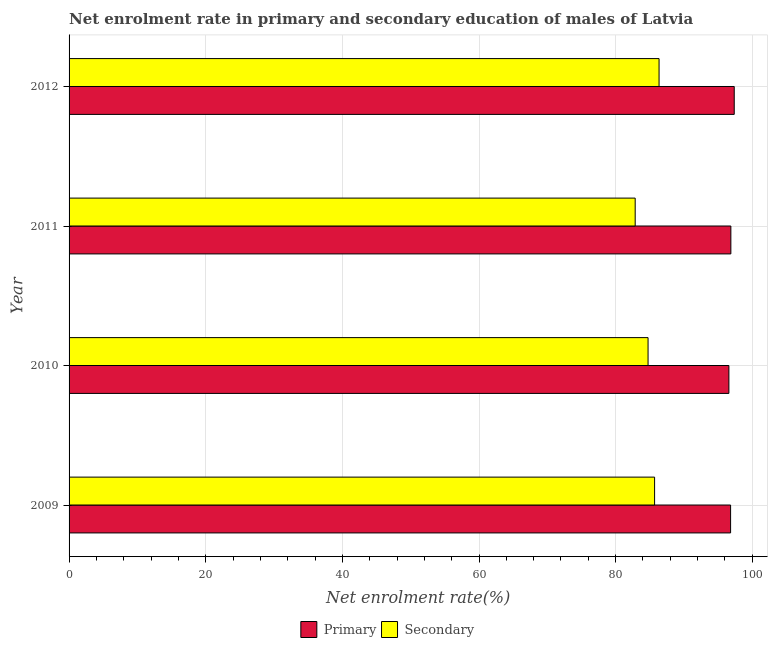Are the number of bars per tick equal to the number of legend labels?
Make the answer very short. Yes. Are the number of bars on each tick of the Y-axis equal?
Give a very brief answer. Yes. In how many cases, is the number of bars for a given year not equal to the number of legend labels?
Give a very brief answer. 0. What is the enrollment rate in primary education in 2009?
Offer a very short reply. 96.82. Across all years, what is the maximum enrollment rate in secondary education?
Give a very brief answer. 86.36. Across all years, what is the minimum enrollment rate in primary education?
Offer a terse response. 96.58. In which year was the enrollment rate in primary education maximum?
Your answer should be very brief. 2012. In which year was the enrollment rate in primary education minimum?
Give a very brief answer. 2010. What is the total enrollment rate in secondary education in the graph?
Provide a short and direct response. 339.66. What is the difference between the enrollment rate in primary education in 2011 and that in 2012?
Keep it short and to the point. -0.49. What is the difference between the enrollment rate in secondary education in 2009 and the enrollment rate in primary education in 2010?
Your response must be concise. -10.88. What is the average enrollment rate in primary education per year?
Your answer should be very brief. 96.91. In the year 2012, what is the difference between the enrollment rate in primary education and enrollment rate in secondary education?
Make the answer very short. 11. In how many years, is the enrollment rate in primary education greater than 64 %?
Your answer should be compact. 4. Is the enrollment rate in secondary education in 2009 less than that in 2012?
Provide a short and direct response. Yes. What is the difference between the highest and the second highest enrollment rate in primary education?
Your answer should be compact. 0.49. What is the difference between the highest and the lowest enrollment rate in secondary education?
Give a very brief answer. 3.49. What does the 1st bar from the top in 2012 represents?
Your answer should be compact. Secondary. What does the 2nd bar from the bottom in 2011 represents?
Offer a terse response. Secondary. How many bars are there?
Your response must be concise. 8. Are all the bars in the graph horizontal?
Provide a short and direct response. Yes. How many years are there in the graph?
Ensure brevity in your answer.  4. Does the graph contain grids?
Provide a succinct answer. Yes. How many legend labels are there?
Your answer should be very brief. 2. What is the title of the graph?
Keep it short and to the point. Net enrolment rate in primary and secondary education of males of Latvia. Does "National Tourists" appear as one of the legend labels in the graph?
Your response must be concise. No. What is the label or title of the X-axis?
Give a very brief answer. Net enrolment rate(%). What is the label or title of the Y-axis?
Your answer should be very brief. Year. What is the Net enrolment rate(%) of Primary in 2009?
Your answer should be very brief. 96.82. What is the Net enrolment rate(%) of Secondary in 2009?
Offer a very short reply. 85.7. What is the Net enrolment rate(%) of Primary in 2010?
Your answer should be very brief. 96.58. What is the Net enrolment rate(%) in Secondary in 2010?
Give a very brief answer. 84.74. What is the Net enrolment rate(%) in Primary in 2011?
Give a very brief answer. 96.86. What is the Net enrolment rate(%) in Secondary in 2011?
Your answer should be very brief. 82.86. What is the Net enrolment rate(%) in Primary in 2012?
Provide a succinct answer. 97.36. What is the Net enrolment rate(%) of Secondary in 2012?
Provide a short and direct response. 86.36. Across all years, what is the maximum Net enrolment rate(%) of Primary?
Give a very brief answer. 97.36. Across all years, what is the maximum Net enrolment rate(%) in Secondary?
Provide a short and direct response. 86.36. Across all years, what is the minimum Net enrolment rate(%) in Primary?
Make the answer very short. 96.58. Across all years, what is the minimum Net enrolment rate(%) in Secondary?
Give a very brief answer. 82.86. What is the total Net enrolment rate(%) in Primary in the graph?
Your answer should be very brief. 387.62. What is the total Net enrolment rate(%) in Secondary in the graph?
Your answer should be very brief. 339.66. What is the difference between the Net enrolment rate(%) of Primary in 2009 and that in 2010?
Give a very brief answer. 0.25. What is the difference between the Net enrolment rate(%) in Secondary in 2009 and that in 2010?
Offer a terse response. 0.96. What is the difference between the Net enrolment rate(%) in Primary in 2009 and that in 2011?
Give a very brief answer. -0.04. What is the difference between the Net enrolment rate(%) of Secondary in 2009 and that in 2011?
Offer a terse response. 2.84. What is the difference between the Net enrolment rate(%) in Primary in 2009 and that in 2012?
Keep it short and to the point. -0.53. What is the difference between the Net enrolment rate(%) in Secondary in 2009 and that in 2012?
Your response must be concise. -0.65. What is the difference between the Net enrolment rate(%) of Primary in 2010 and that in 2011?
Keep it short and to the point. -0.29. What is the difference between the Net enrolment rate(%) in Secondary in 2010 and that in 2011?
Keep it short and to the point. 1.88. What is the difference between the Net enrolment rate(%) in Primary in 2010 and that in 2012?
Keep it short and to the point. -0.78. What is the difference between the Net enrolment rate(%) of Secondary in 2010 and that in 2012?
Make the answer very short. -1.61. What is the difference between the Net enrolment rate(%) in Primary in 2011 and that in 2012?
Your response must be concise. -0.49. What is the difference between the Net enrolment rate(%) of Secondary in 2011 and that in 2012?
Ensure brevity in your answer.  -3.49. What is the difference between the Net enrolment rate(%) of Primary in 2009 and the Net enrolment rate(%) of Secondary in 2010?
Your response must be concise. 12.08. What is the difference between the Net enrolment rate(%) in Primary in 2009 and the Net enrolment rate(%) in Secondary in 2011?
Your response must be concise. 13.96. What is the difference between the Net enrolment rate(%) of Primary in 2009 and the Net enrolment rate(%) of Secondary in 2012?
Offer a very short reply. 10.47. What is the difference between the Net enrolment rate(%) in Primary in 2010 and the Net enrolment rate(%) in Secondary in 2011?
Provide a short and direct response. 13.72. What is the difference between the Net enrolment rate(%) in Primary in 2010 and the Net enrolment rate(%) in Secondary in 2012?
Your answer should be very brief. 10.22. What is the difference between the Net enrolment rate(%) of Primary in 2011 and the Net enrolment rate(%) of Secondary in 2012?
Offer a very short reply. 10.51. What is the average Net enrolment rate(%) of Primary per year?
Provide a short and direct response. 96.91. What is the average Net enrolment rate(%) in Secondary per year?
Offer a terse response. 84.92. In the year 2009, what is the difference between the Net enrolment rate(%) in Primary and Net enrolment rate(%) in Secondary?
Ensure brevity in your answer.  11.12. In the year 2010, what is the difference between the Net enrolment rate(%) of Primary and Net enrolment rate(%) of Secondary?
Offer a terse response. 11.83. In the year 2011, what is the difference between the Net enrolment rate(%) in Primary and Net enrolment rate(%) in Secondary?
Offer a terse response. 14. In the year 2012, what is the difference between the Net enrolment rate(%) of Primary and Net enrolment rate(%) of Secondary?
Keep it short and to the point. 11. What is the ratio of the Net enrolment rate(%) of Secondary in 2009 to that in 2010?
Your answer should be compact. 1.01. What is the ratio of the Net enrolment rate(%) of Primary in 2009 to that in 2011?
Offer a very short reply. 1. What is the ratio of the Net enrolment rate(%) of Secondary in 2009 to that in 2011?
Your response must be concise. 1.03. What is the ratio of the Net enrolment rate(%) of Primary in 2009 to that in 2012?
Your response must be concise. 0.99. What is the ratio of the Net enrolment rate(%) in Primary in 2010 to that in 2011?
Provide a short and direct response. 1. What is the ratio of the Net enrolment rate(%) of Secondary in 2010 to that in 2011?
Make the answer very short. 1.02. What is the ratio of the Net enrolment rate(%) in Secondary in 2010 to that in 2012?
Keep it short and to the point. 0.98. What is the ratio of the Net enrolment rate(%) of Primary in 2011 to that in 2012?
Ensure brevity in your answer.  0.99. What is the ratio of the Net enrolment rate(%) in Secondary in 2011 to that in 2012?
Give a very brief answer. 0.96. What is the difference between the highest and the second highest Net enrolment rate(%) in Primary?
Make the answer very short. 0.49. What is the difference between the highest and the second highest Net enrolment rate(%) of Secondary?
Ensure brevity in your answer.  0.65. What is the difference between the highest and the lowest Net enrolment rate(%) of Primary?
Your answer should be very brief. 0.78. What is the difference between the highest and the lowest Net enrolment rate(%) of Secondary?
Offer a very short reply. 3.49. 